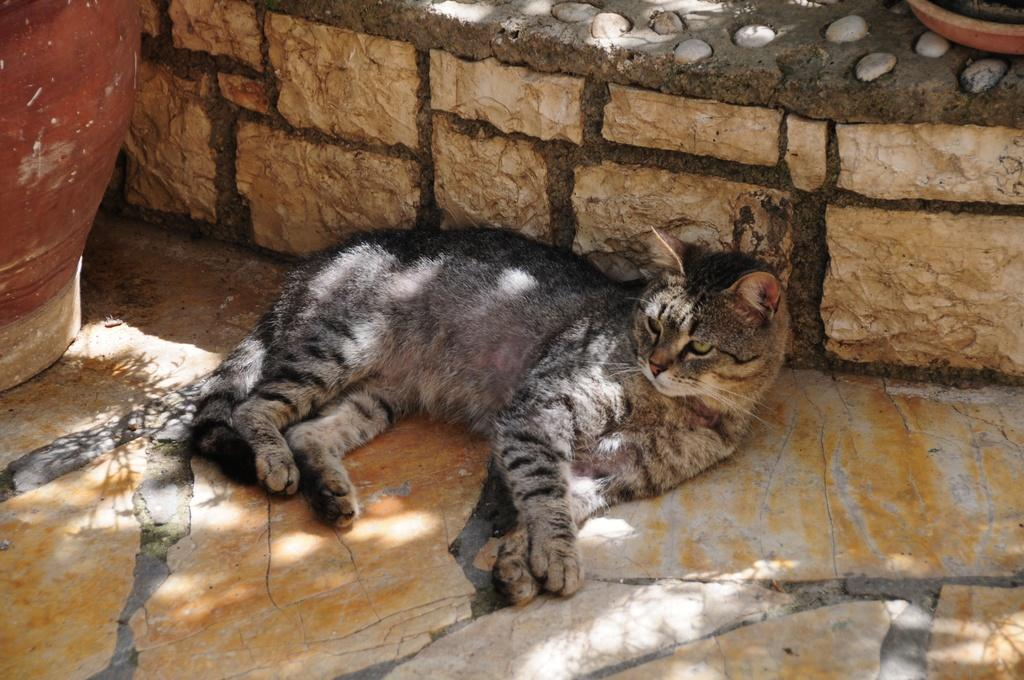What type of animal is in the image? There is a cat in the image. What other object can be seen in the image besides the cat? There is a plant pot in the image. What is the weight of the church in the image? There is no church present in the image, so it is not possible to determine its weight. 